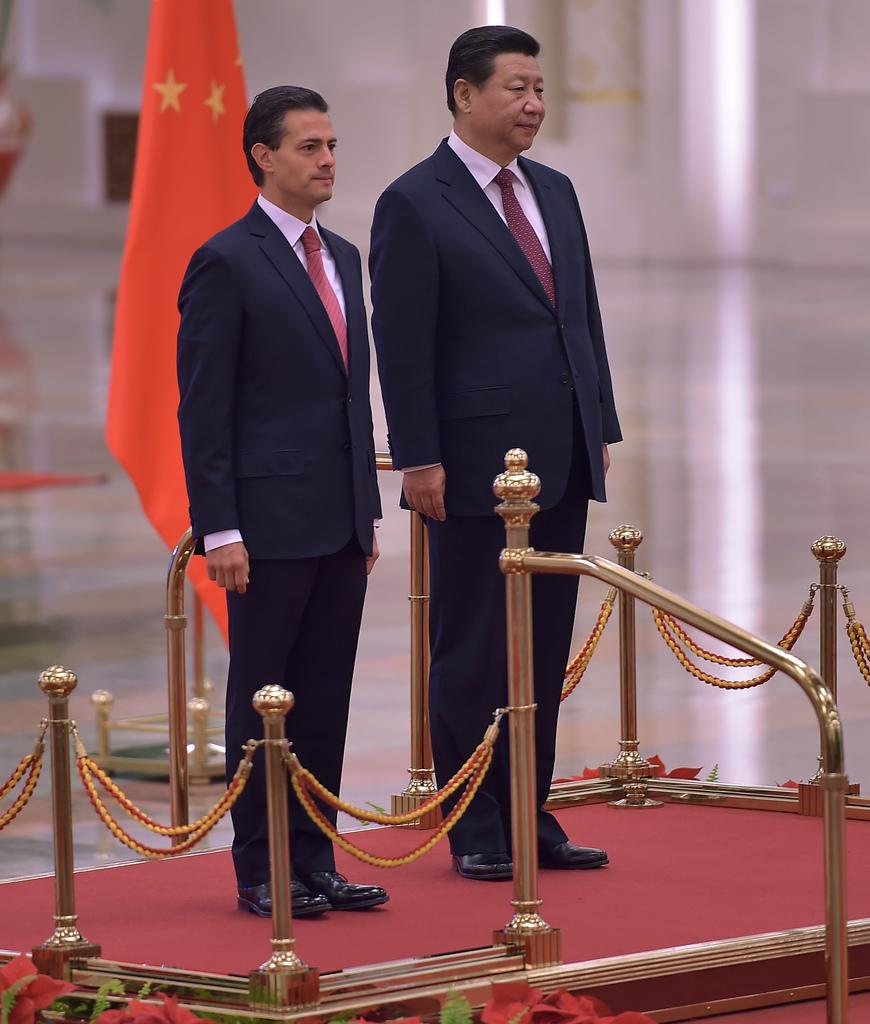What is located at the bottom of the image? There is a fencing at the bottom of the image. Who or what can be seen behind the fencing? Two persons are standing behind the fencing. What can be seen in the background of the image? There is a pole in the background. What is attached to the pole? A flag is present on the pole. What type of tank can be seen in the image? There is no tank present in the image. What season is depicted in the image? The provided facts do not give any information about the season, so it cannot be determined from the image. 